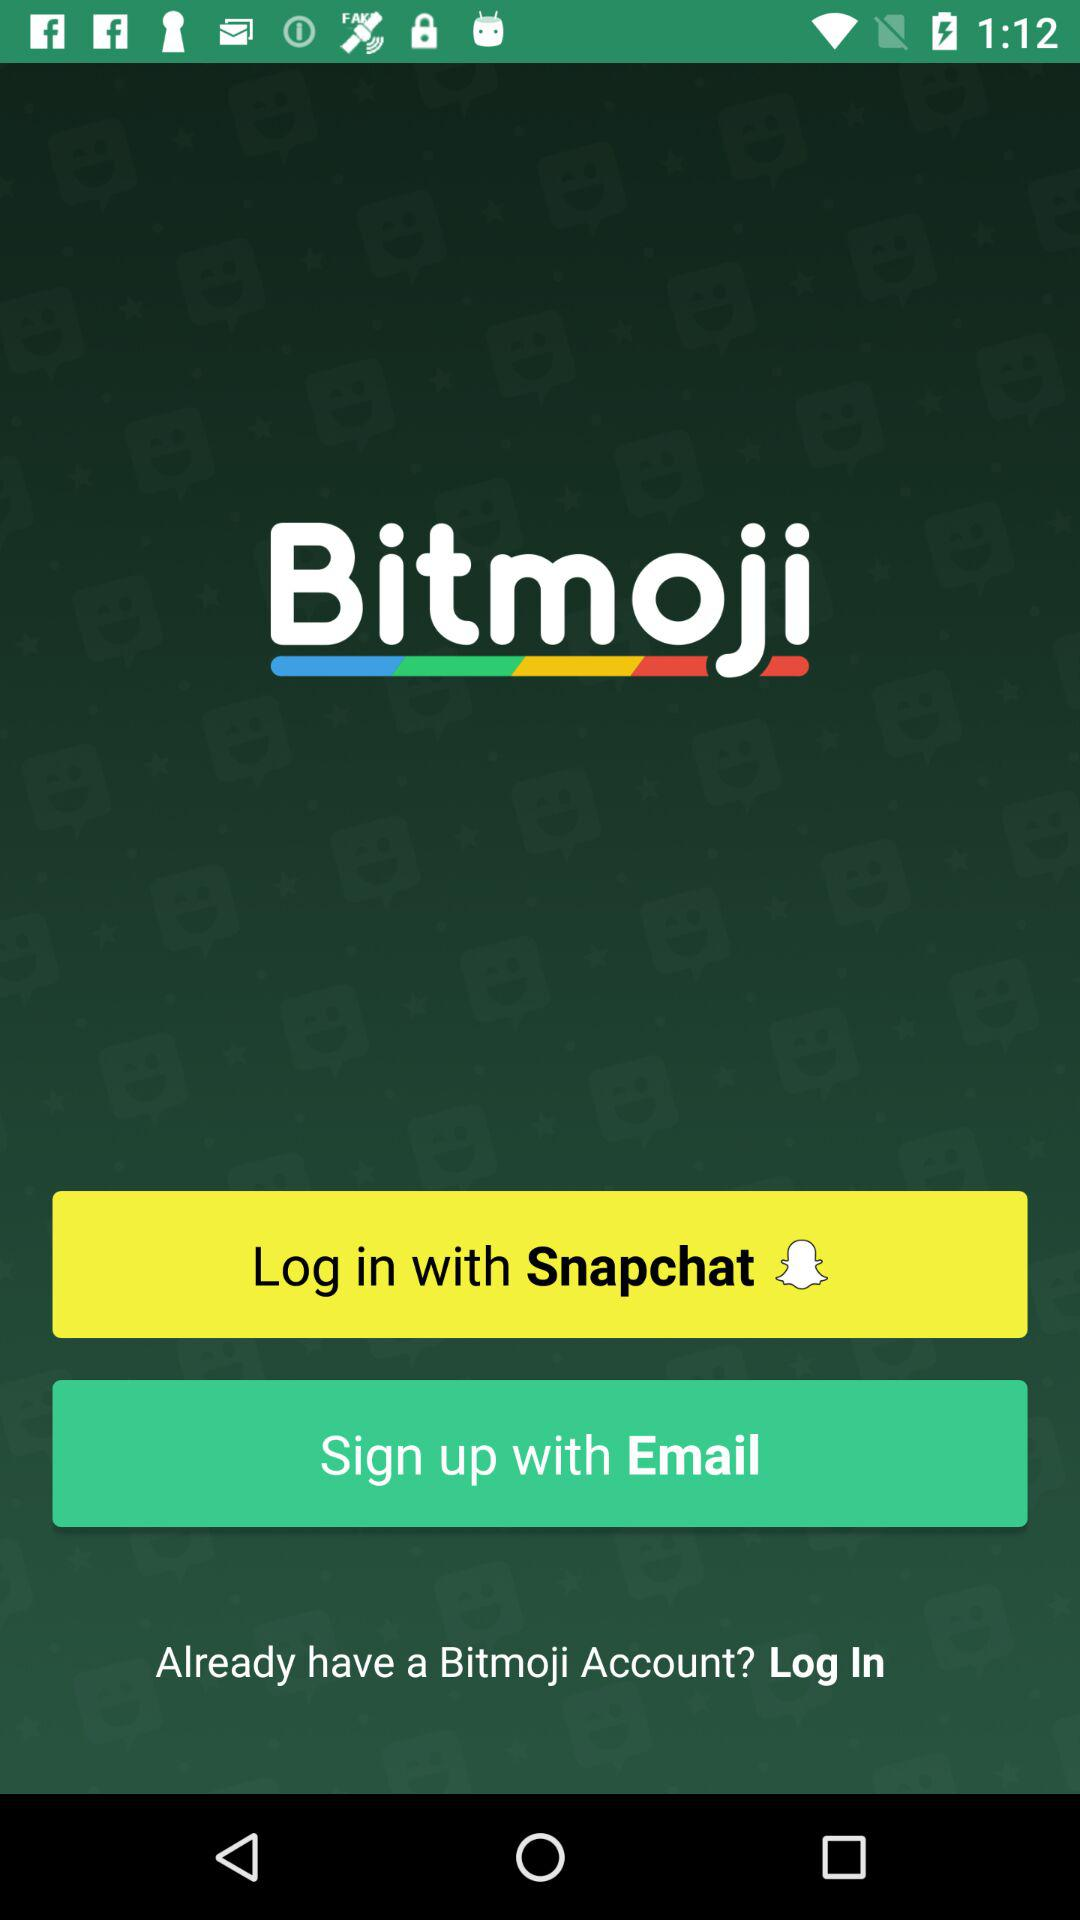What app can be used to log in? The app that can be used to log in is "Snapchat". 